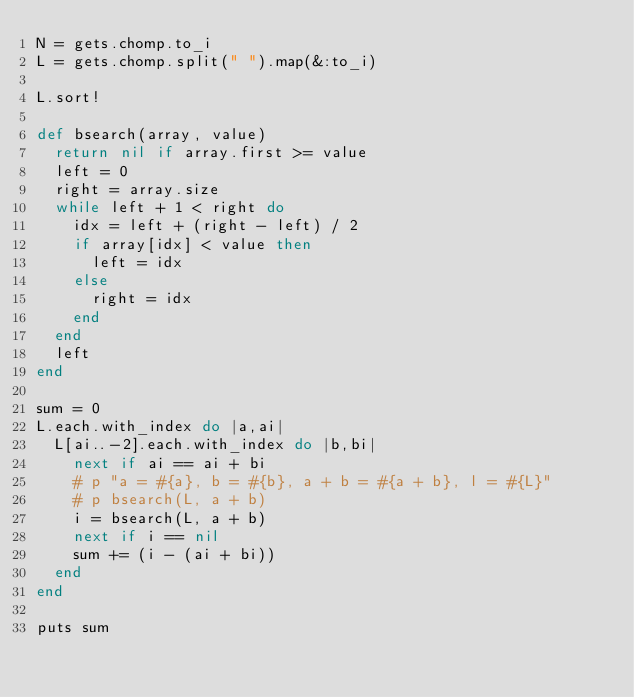<code> <loc_0><loc_0><loc_500><loc_500><_Ruby_>N = gets.chomp.to_i
L = gets.chomp.split(" ").map(&:to_i)

L.sort!

def bsearch(array, value)
  return nil if array.first >= value
  left = 0
  right = array.size
  while left + 1 < right do
    idx = left + (right - left) / 2
    if array[idx] < value then
      left = idx
    else
      right = idx
    end
  end
  left
end

sum = 0
L.each.with_index do |a,ai|
  L[ai..-2].each.with_index do |b,bi|
    next if ai == ai + bi
    # p "a = #{a}, b = #{b}, a + b = #{a + b}, l = #{L}"
    # p bsearch(L, a + b)
    i = bsearch(L, a + b)
    next if i == nil
    sum += (i - (ai + bi))
  end
end

puts sum</code> 